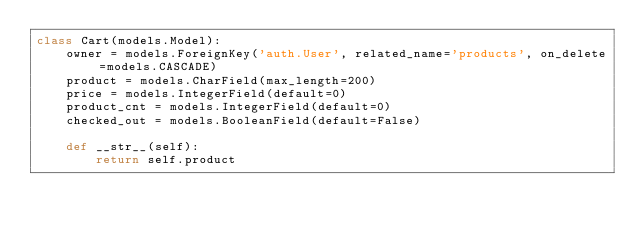<code> <loc_0><loc_0><loc_500><loc_500><_Python_>class Cart(models.Model):
    owner = models.ForeignKey('auth.User', related_name='products', on_delete=models.CASCADE)
    product = models.CharField(max_length=200)
    price = models.IntegerField(default=0)
    product_cnt = models.IntegerField(default=0)
    checked_out = models.BooleanField(default=False)

    def __str__(self):
        return self.product</code> 